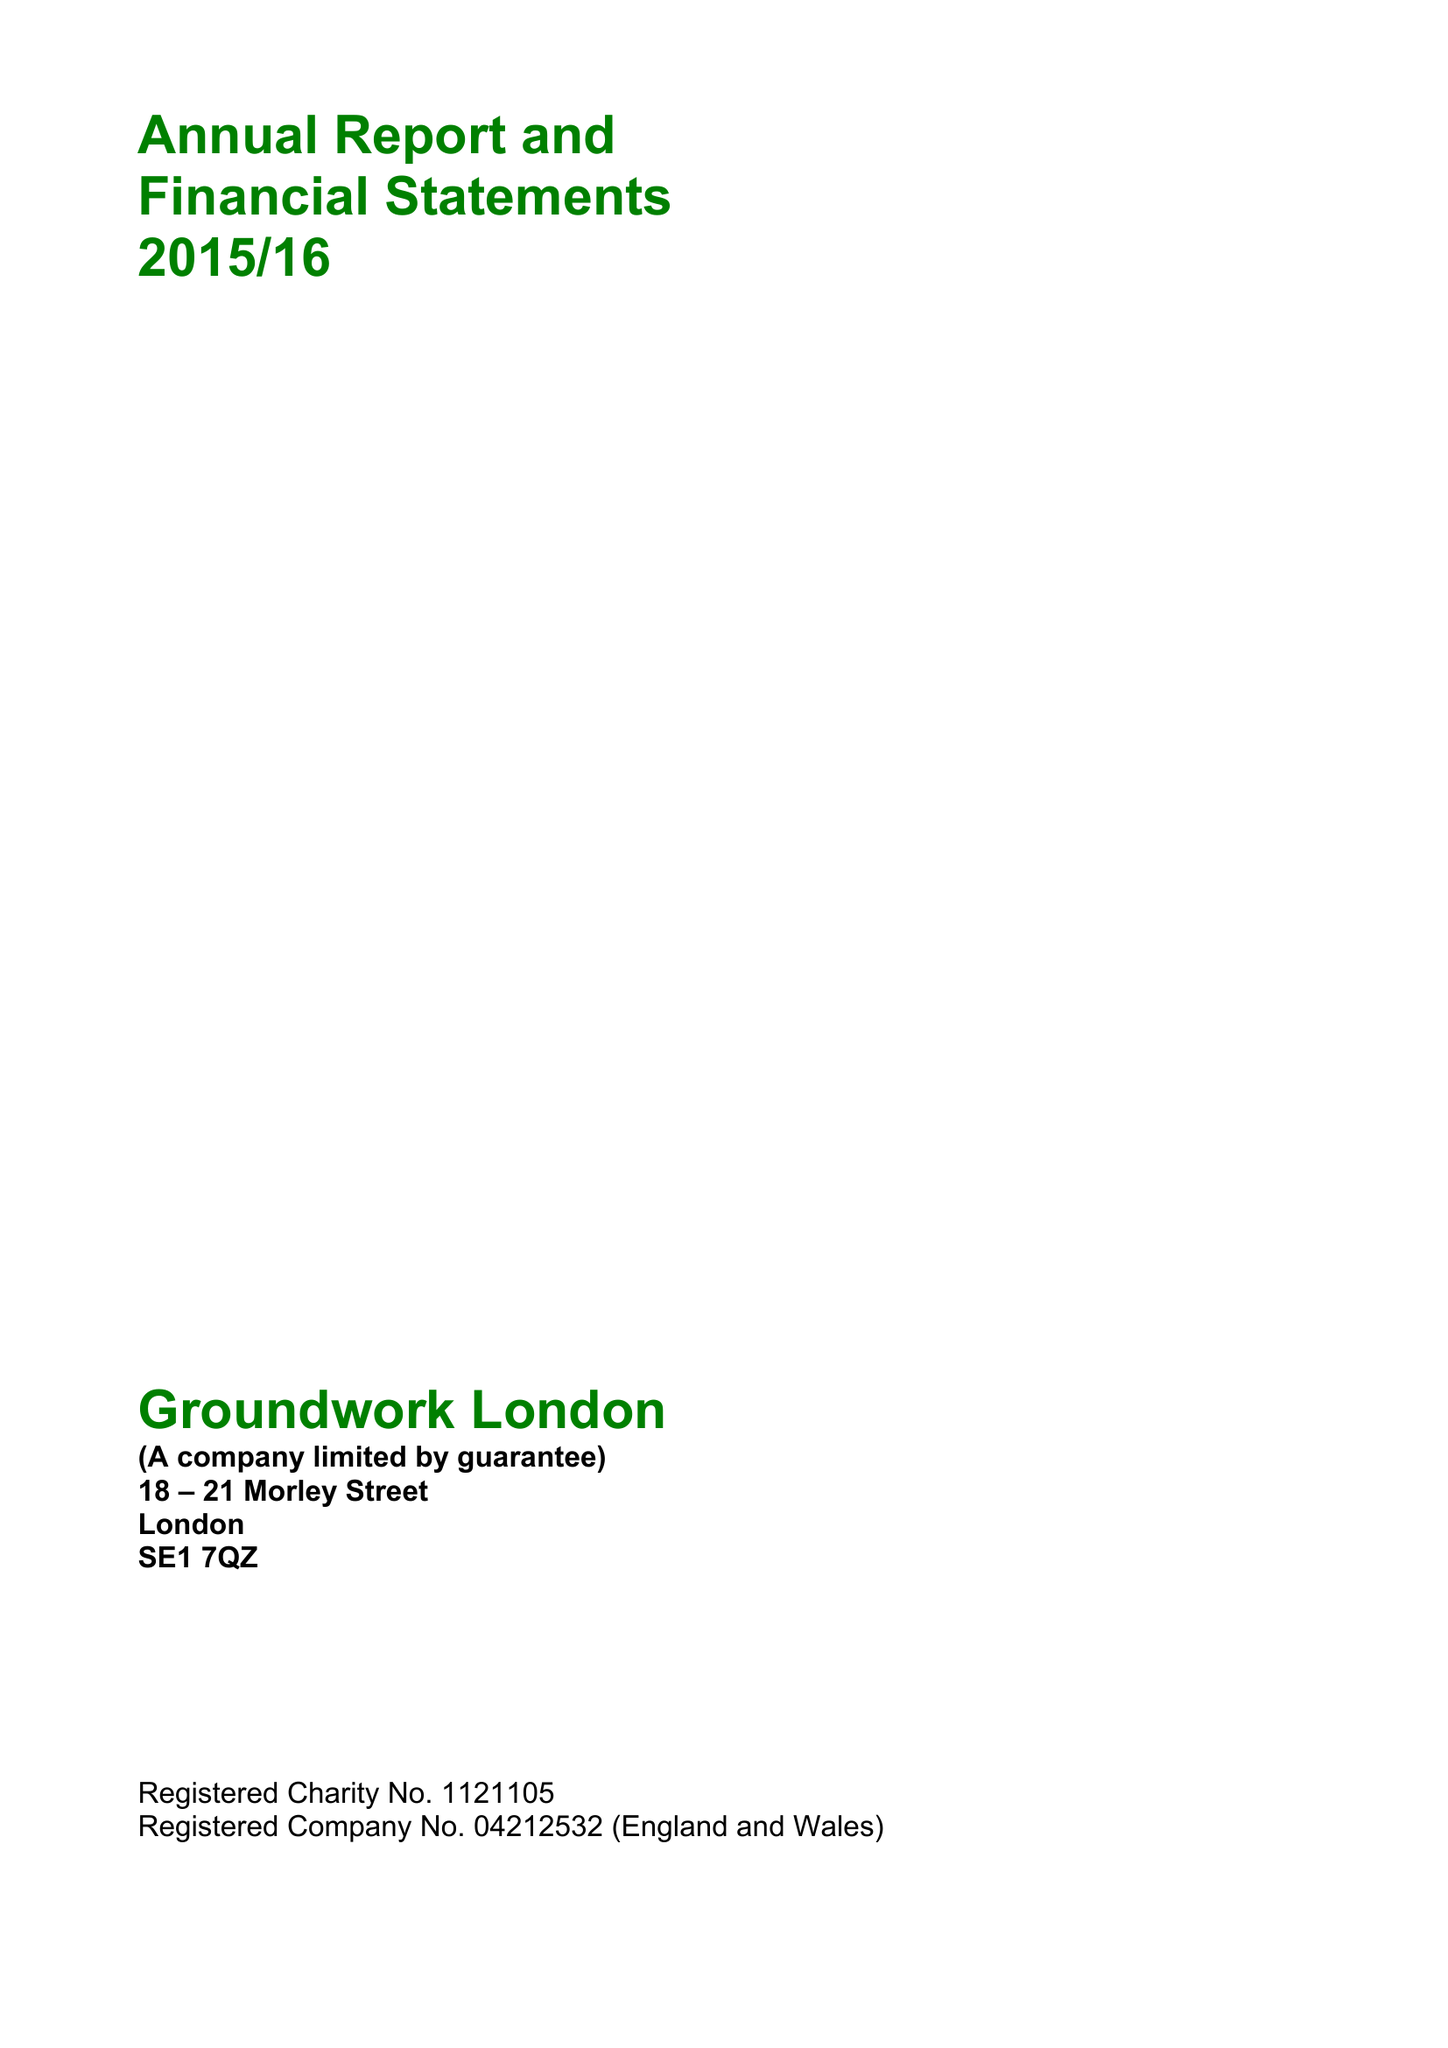What is the value for the income_annually_in_british_pounds?
Answer the question using a single word or phrase. 11313255.00 